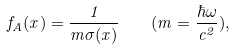<formula> <loc_0><loc_0><loc_500><loc_500>f _ { A } ( x ) = \frac { 1 } { m \sigma ( x ) } \quad ( m = \frac { \hbar { \omega } } { c ^ { 2 } } ) ,</formula> 